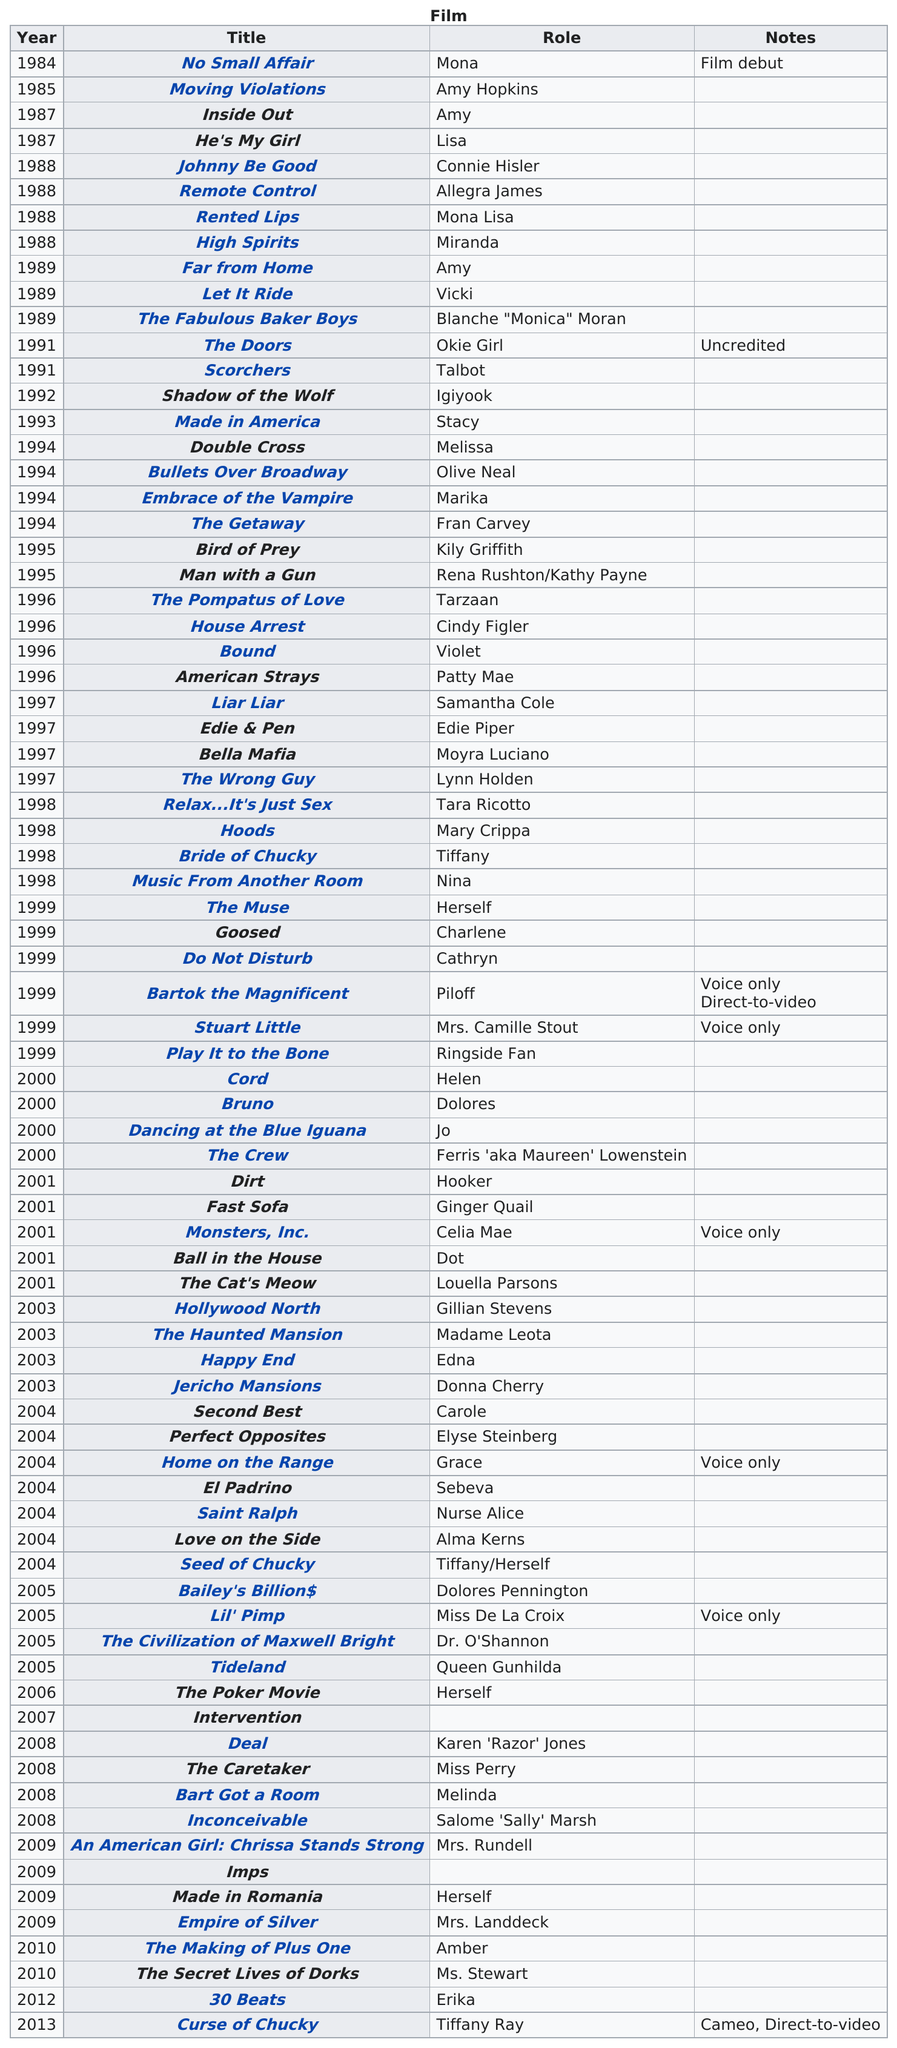Give some essential details in this illustration. In 2004, the most credits were issued. Jennifer Tilly played herself in films numbered 4. The film that features their role is "Shadow of the Wolf. Jennifer Tilly has played herself in four movies. No Small Affair was the movie that was also a film debut. 